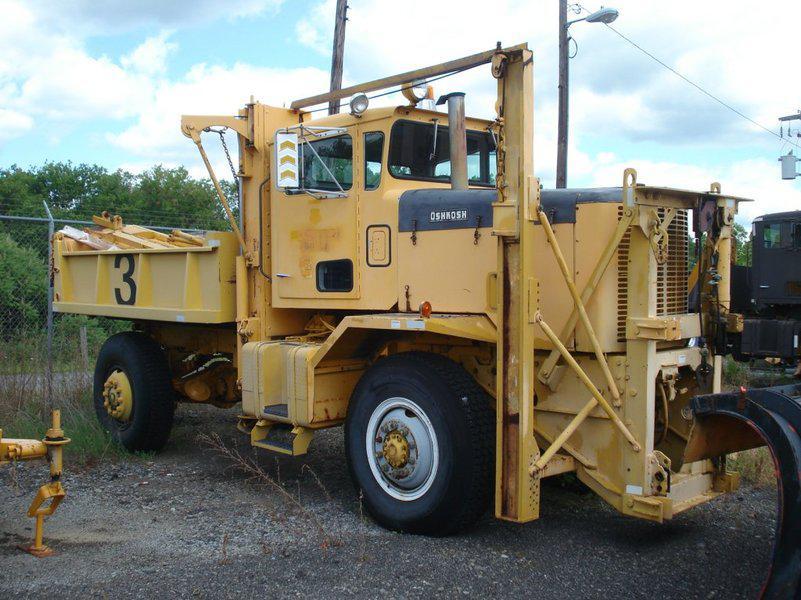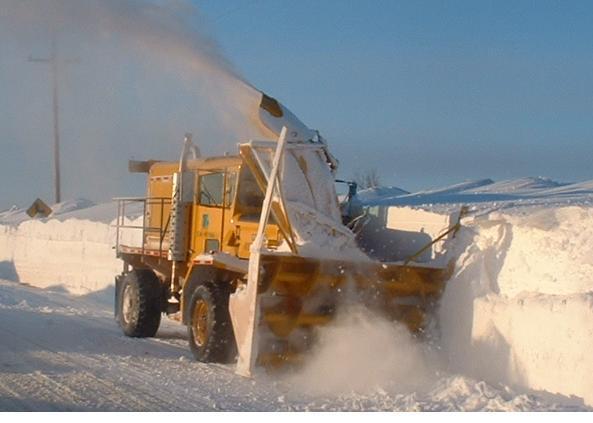The first image is the image on the left, the second image is the image on the right. For the images shown, is this caption "There is exactly one snow plow in the right image." true? Answer yes or no. Yes. 